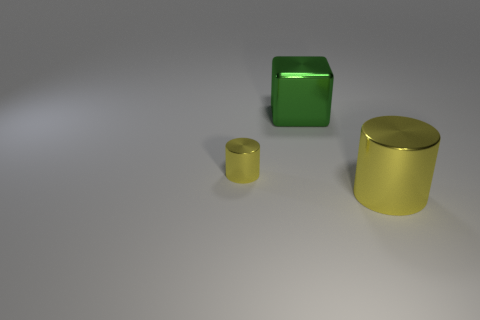Add 1 small yellow objects. How many objects exist? 4 Subtract all cylinders. How many objects are left? 1 Add 3 small shiny things. How many small shiny things exist? 4 Subtract 0 yellow balls. How many objects are left? 3 Subtract all blue rubber cubes. Subtract all large green cubes. How many objects are left? 2 Add 2 big metallic cubes. How many big metallic cubes are left? 3 